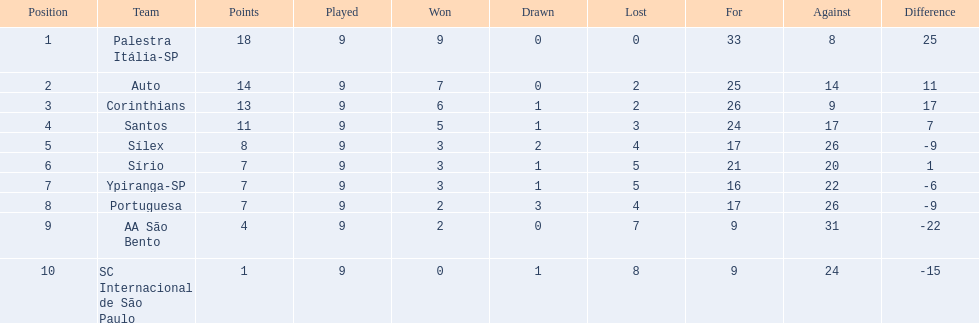What were all the teams that competed in 1926 brazilian football? Palestra Itália-SP, Auto, Corinthians, Santos, Sílex, Sírio, Ypiranga-SP, Portuguesa, AA São Bento, SC Internacional de São Paulo. Which of these had zero games lost? Palestra Itália-SP. 